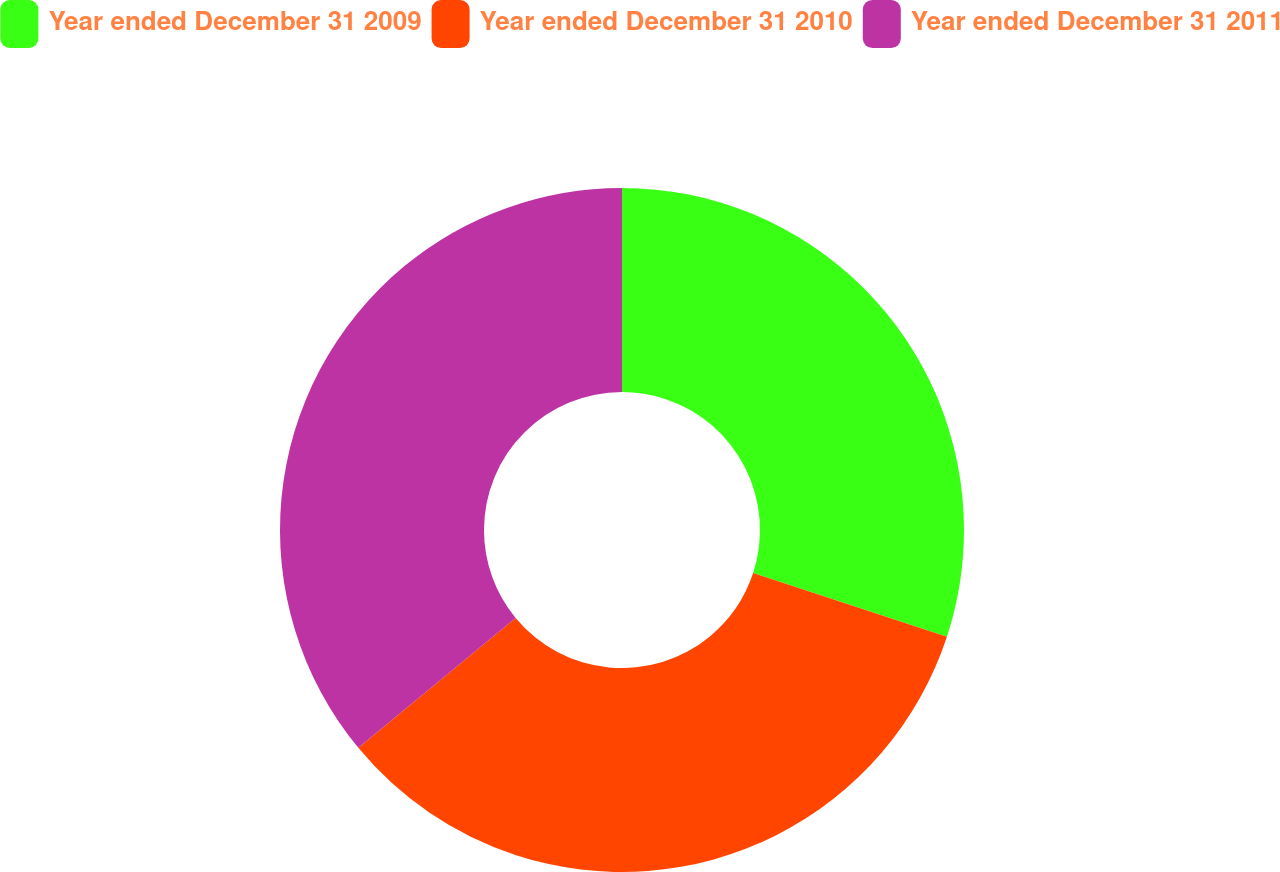<chart> <loc_0><loc_0><loc_500><loc_500><pie_chart><fcel>Year ended December 31 2009<fcel>Year ended December 31 2010<fcel>Year ended December 31 2011<nl><fcel>30.05%<fcel>33.96%<fcel>35.99%<nl></chart> 